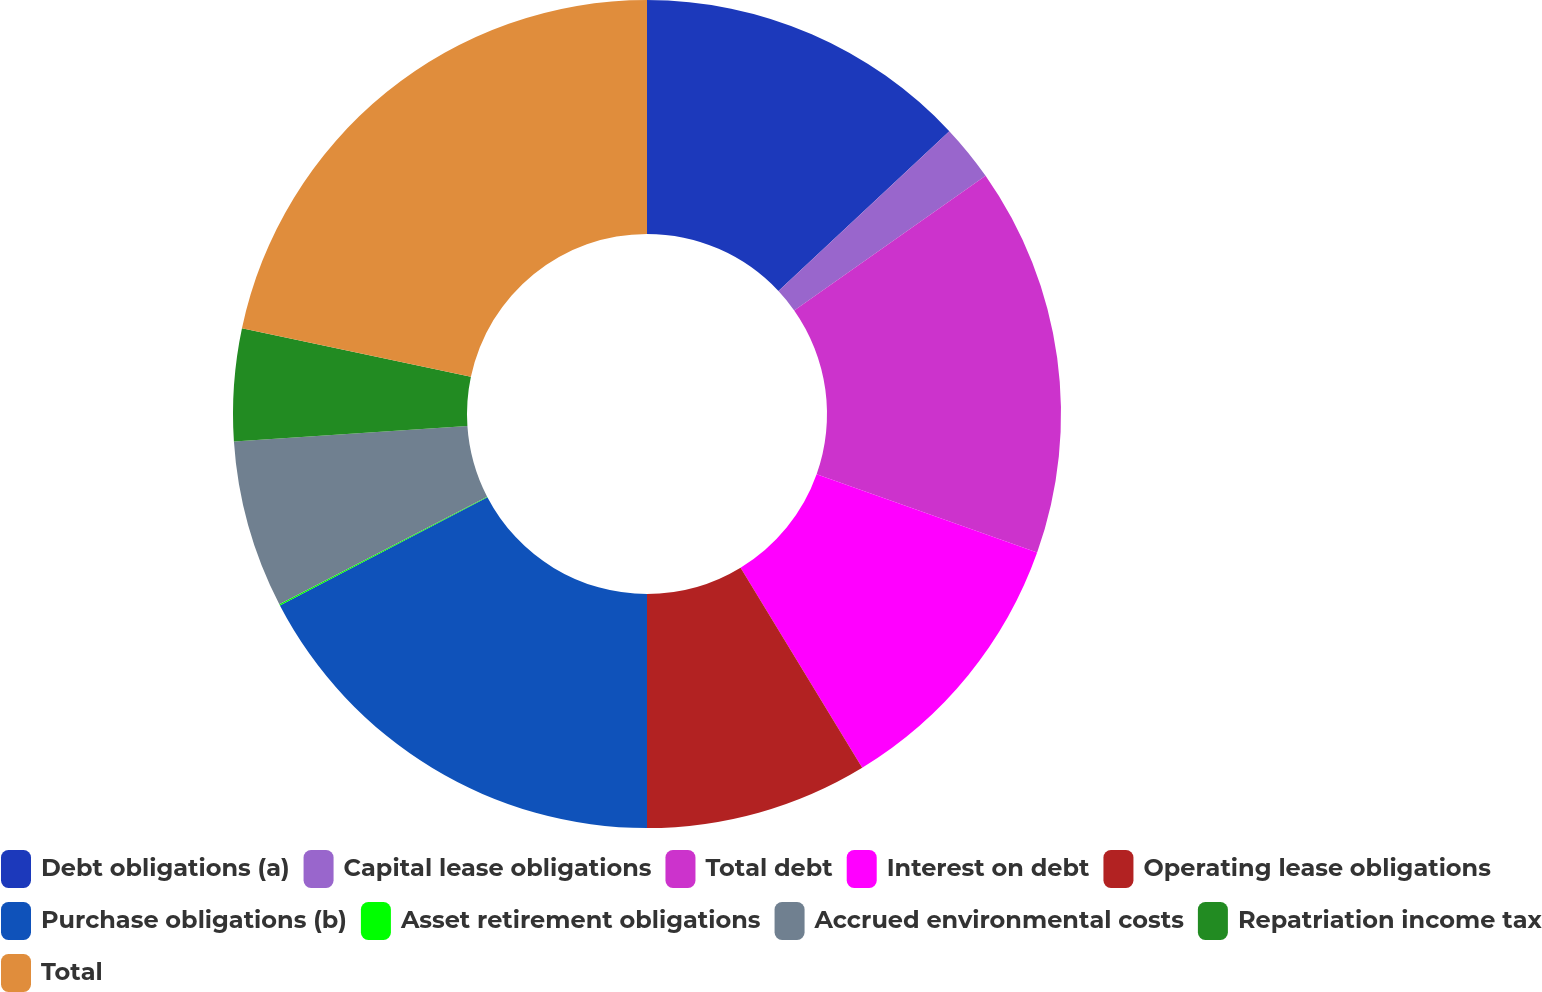Convert chart to OTSL. <chart><loc_0><loc_0><loc_500><loc_500><pie_chart><fcel>Debt obligations (a)<fcel>Capital lease obligations<fcel>Total debt<fcel>Interest on debt<fcel>Operating lease obligations<fcel>Purchase obligations (b)<fcel>Asset retirement obligations<fcel>Accrued environmental costs<fcel>Repatriation income tax<fcel>Total<nl><fcel>13.03%<fcel>2.21%<fcel>15.19%<fcel>10.87%<fcel>8.7%<fcel>17.35%<fcel>0.05%<fcel>6.54%<fcel>4.38%<fcel>21.68%<nl></chart> 